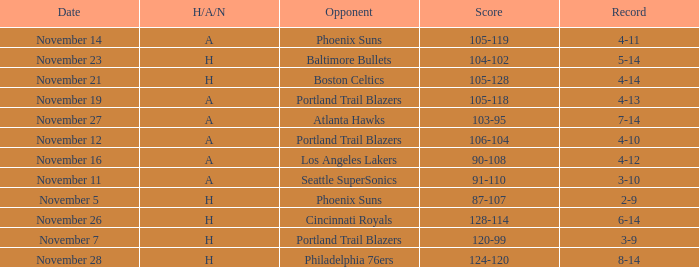On what Date was the Score 106-104 against the Portland Trail Blazers? November 12. 